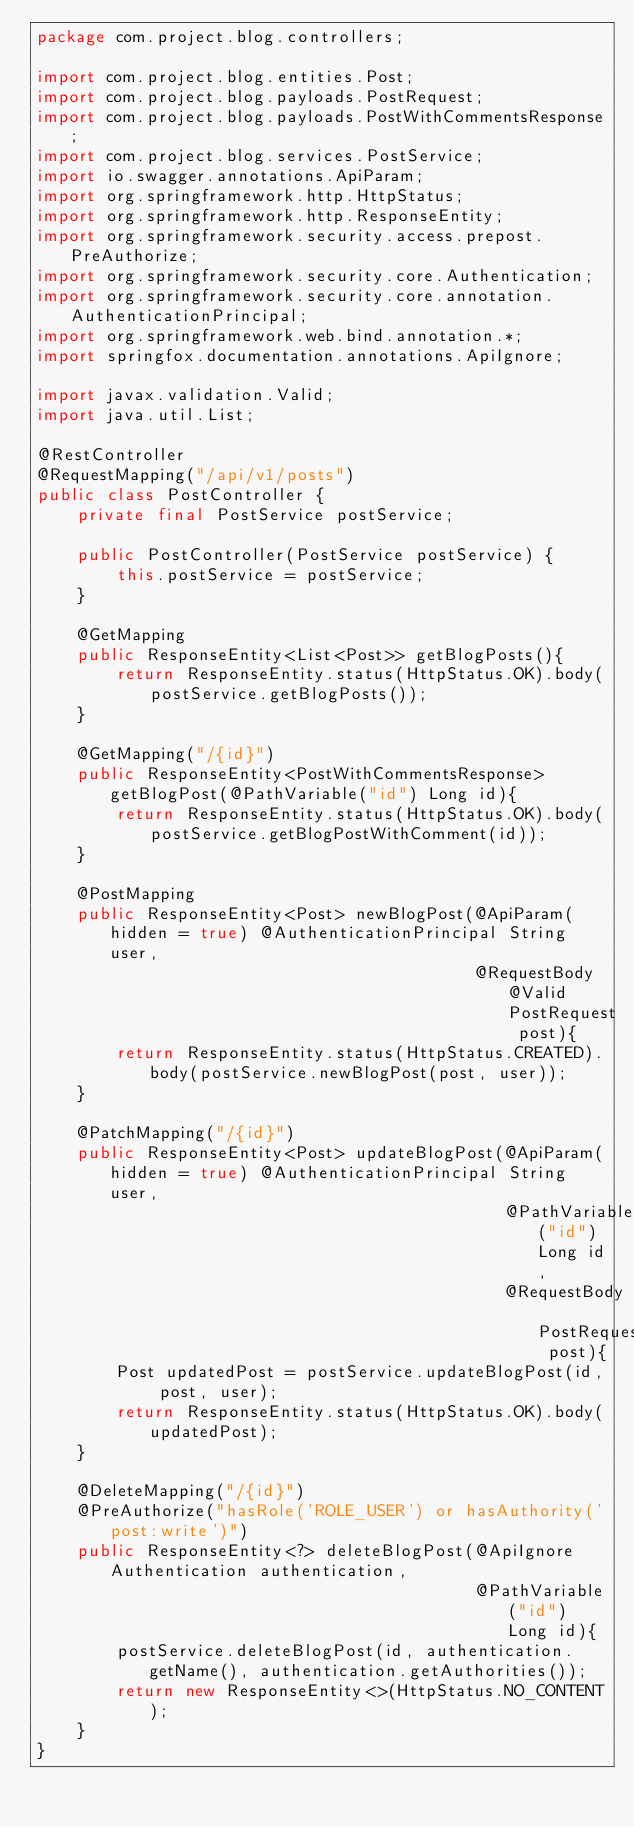Convert code to text. <code><loc_0><loc_0><loc_500><loc_500><_Java_>package com.project.blog.controllers;

import com.project.blog.entities.Post;
import com.project.blog.payloads.PostRequest;
import com.project.blog.payloads.PostWithCommentsResponse;
import com.project.blog.services.PostService;
import io.swagger.annotations.ApiParam;
import org.springframework.http.HttpStatus;
import org.springframework.http.ResponseEntity;
import org.springframework.security.access.prepost.PreAuthorize;
import org.springframework.security.core.Authentication;
import org.springframework.security.core.annotation.AuthenticationPrincipal;
import org.springframework.web.bind.annotation.*;
import springfox.documentation.annotations.ApiIgnore;

import javax.validation.Valid;
import java.util.List;

@RestController
@RequestMapping("/api/v1/posts")
public class PostController {
    private final PostService postService;

    public PostController(PostService postService) {
        this.postService = postService;
    }

    @GetMapping
    public ResponseEntity<List<Post>> getBlogPosts(){
        return ResponseEntity.status(HttpStatus.OK).body(postService.getBlogPosts());
    }

    @GetMapping("/{id}")
    public ResponseEntity<PostWithCommentsResponse> getBlogPost(@PathVariable("id") Long id){
        return ResponseEntity.status(HttpStatus.OK).body(postService.getBlogPostWithComment(id));
    }

    @PostMapping
    public ResponseEntity<Post> newBlogPost(@ApiParam(hidden = true) @AuthenticationPrincipal String user,
                                            @RequestBody @Valid PostRequest post){
        return ResponseEntity.status(HttpStatus.CREATED).body(postService.newBlogPost(post, user));
    }

    @PatchMapping("/{id}")
    public ResponseEntity<Post> updateBlogPost(@ApiParam(hidden = true) @AuthenticationPrincipal String user,
                                               @PathVariable("id") Long id,
                                               @RequestBody PostRequest post){
        Post updatedPost = postService.updateBlogPost(id, post, user);
        return ResponseEntity.status(HttpStatus.OK).body(updatedPost);
    }

    @DeleteMapping("/{id}")
    @PreAuthorize("hasRole('ROLE_USER') or hasAuthority('post:write')")
    public ResponseEntity<?> deleteBlogPost(@ApiIgnore Authentication authentication,
                                            @PathVariable("id") Long id){
        postService.deleteBlogPost(id, authentication.getName(), authentication.getAuthorities());
        return new ResponseEntity<>(HttpStatus.NO_CONTENT);
    }
}
</code> 